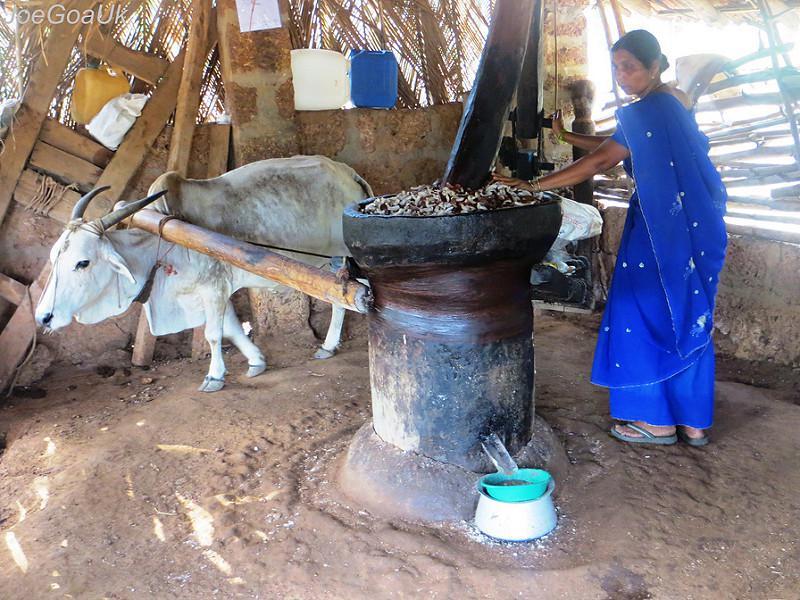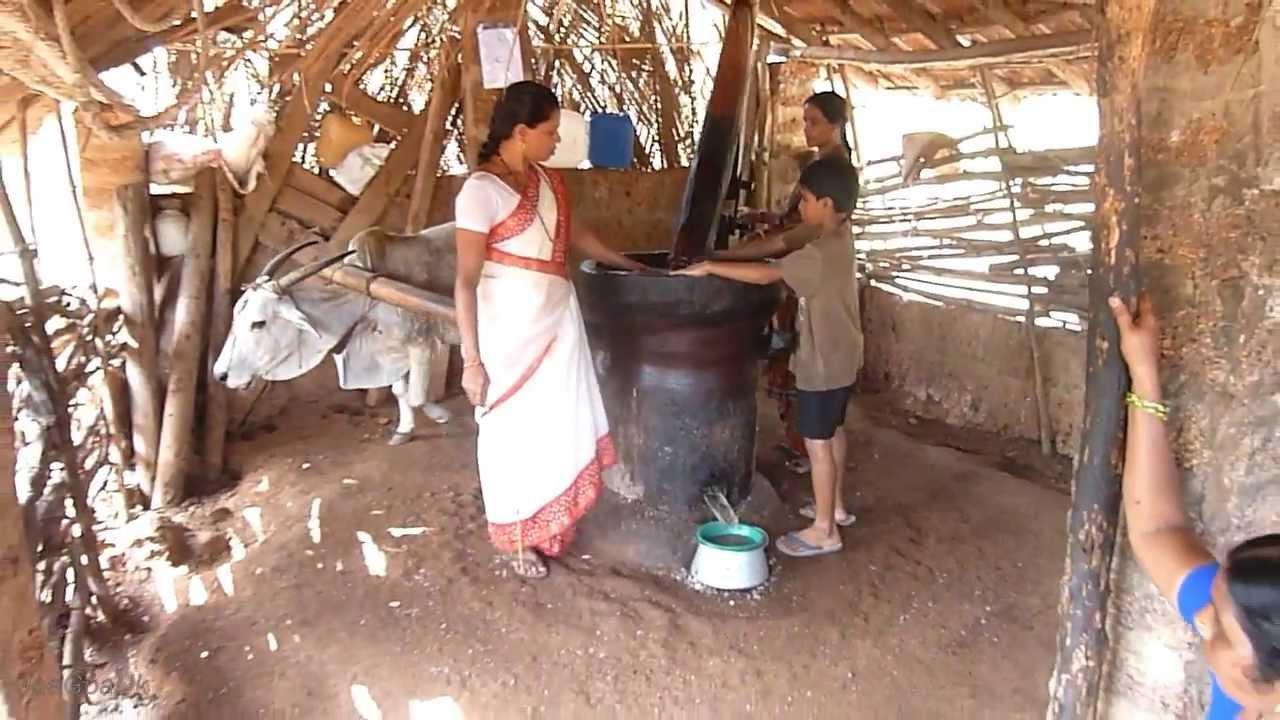The first image is the image on the left, the second image is the image on the right. Assess this claim about the two images: "The man attending the cow in one of the photos is shirtless.". Correct or not? Answer yes or no. No. The first image is the image on the left, the second image is the image on the right. For the images shown, is this caption "There is a green bowl under a spout that comes out from the mill in the left image." true? Answer yes or no. Yes. 